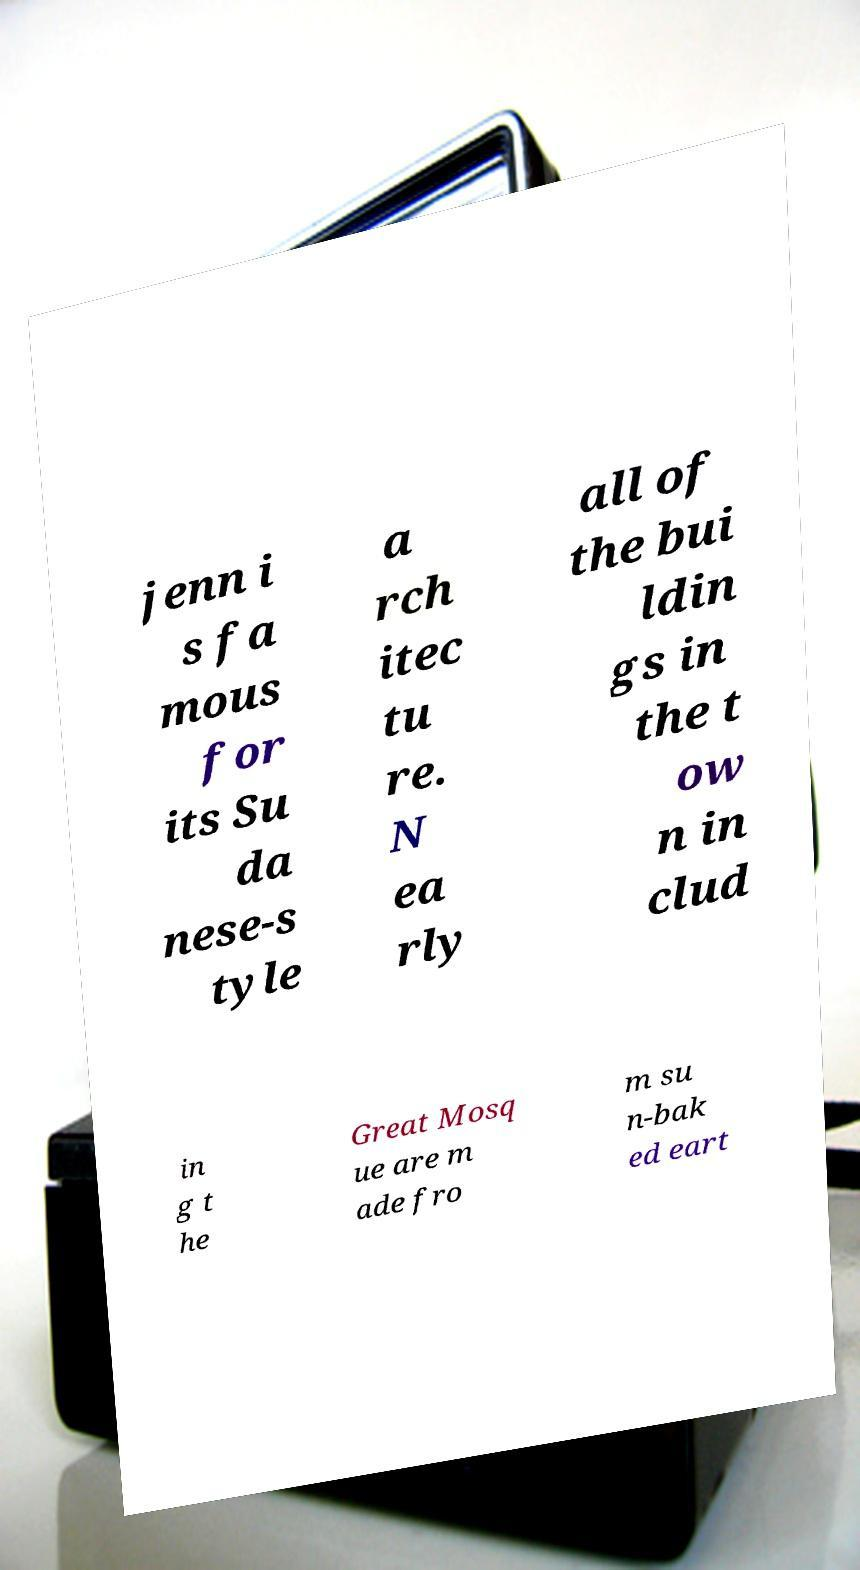Please identify and transcribe the text found in this image. jenn i s fa mous for its Su da nese-s tyle a rch itec tu re. N ea rly all of the bui ldin gs in the t ow n in clud in g t he Great Mosq ue are m ade fro m su n-bak ed eart 